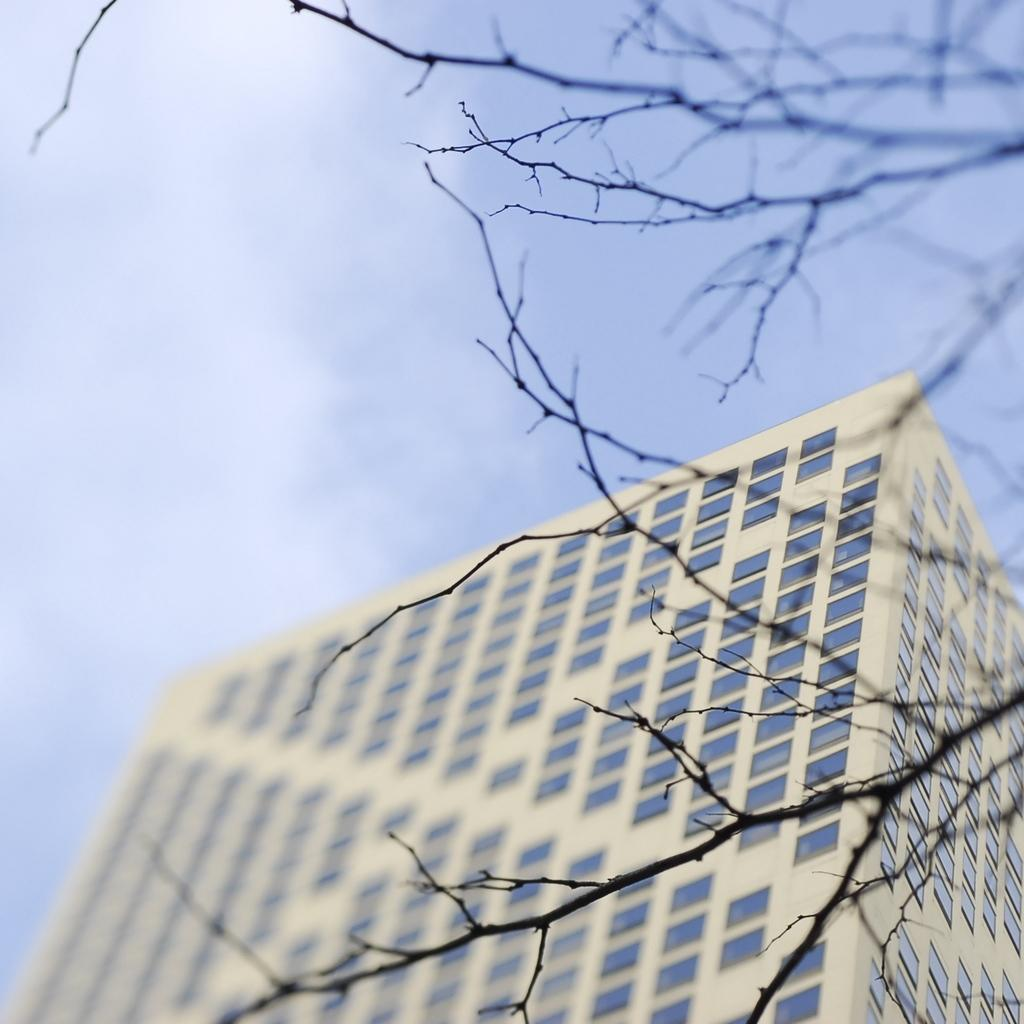What type of structure is present in the image? There is a building in the image. What natural element can be seen in the image? There is a tree in the image. What is visible in the background of the image? The sky is visible in the background of the image. Can you tell me how many kittens are playing with the brush in the image? There are no kittens or brushes present in the image. 